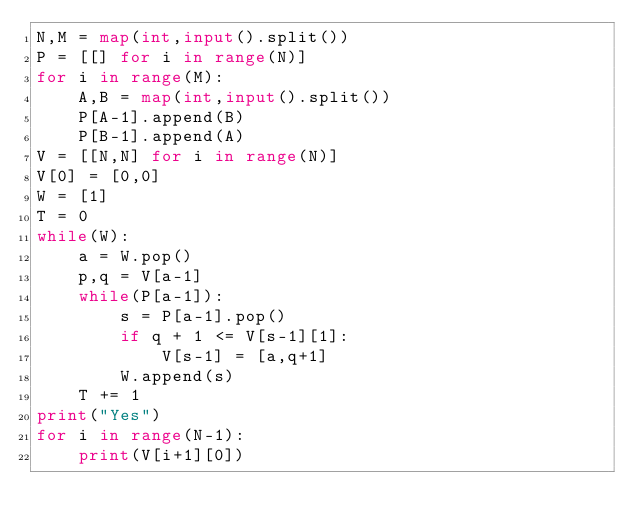<code> <loc_0><loc_0><loc_500><loc_500><_Python_>N,M = map(int,input().split())
P = [[] for i in range(N)]
for i in range(M):
    A,B = map(int,input().split())
    P[A-1].append(B)
    P[B-1].append(A)
V = [[N,N] for i in range(N)]
V[0] = [0,0]
W = [1]
T = 0
while(W):
    a = W.pop()
    p,q = V[a-1]
    while(P[a-1]):
        s = P[a-1].pop()
        if q + 1 <= V[s-1][1]:
            V[s-1] = [a,q+1]
        W.append(s)
    T += 1
print("Yes")
for i in range(N-1):
    print(V[i+1][0])</code> 